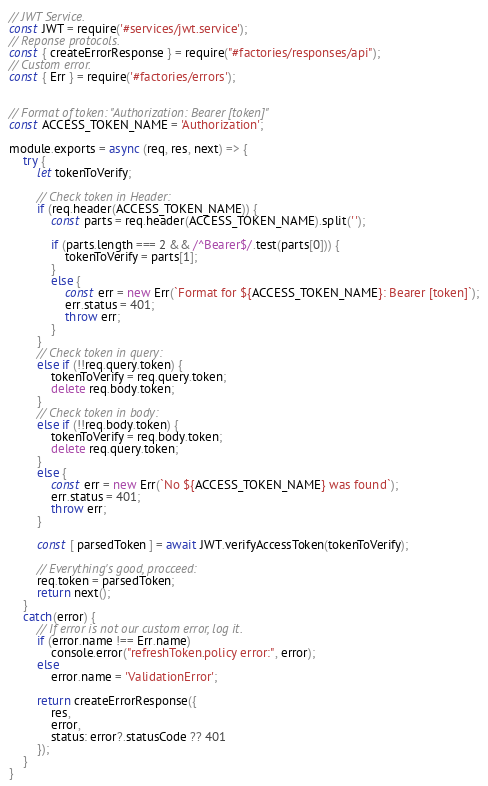Convert code to text. <code><loc_0><loc_0><loc_500><loc_500><_JavaScript_>// JWT Service.
const JWT = require('#services/jwt.service');
// Reponse protocols.
const { createErrorResponse } = require("#factories/responses/api");
// Custom error.
const { Err } = require('#factories/errors');


// Format of token: "Authorization: Bearer [token]"
const ACCESS_TOKEN_NAME = 'Authorization';

module.exports = async (req, res, next) => {
	try {
		let tokenToVerify;

		// Check token in Header:
		if (req.header(ACCESS_TOKEN_NAME)) {
			const parts = req.header(ACCESS_TOKEN_NAME).split(' ');

			if (parts.length === 2 && /^Bearer$/.test(parts[0])) {
				tokenToVerify = parts[1];
			} 
			else {
				const err = new Err(`Format for ${ACCESS_TOKEN_NAME}: Bearer [token]`);
				err.status = 401;
				throw err;
			}
		}
		// Check token in query:
		else if (!!req.query.token) {
			tokenToVerify = req.query.token;
			delete req.body.token;
		}
		// Check token in body:
		else if (!!req.body.token) {
			tokenToVerify = req.body.token;
			delete req.query.token;
		} 
		else {
			const err = new Err(`No ${ACCESS_TOKEN_NAME} was found`);
			err.status = 401;
			throw err;
		}

		const [ parsedToken ] = await JWT.verifyAccessToken(tokenToVerify);

		// Everything's good, procceed:
		req.token = parsedToken;
		return next();
	}
	catch(error) {
		// If error is not our custom error, log it.
		if (error.name !== Err.name)
			console.error("refreshToken.policy error:", error);
		else
			error.name = 'ValidationError';

		return createErrorResponse({
			res, 
			error,
			status: error?.statusCode ?? 401
		});
	}
}
</code> 